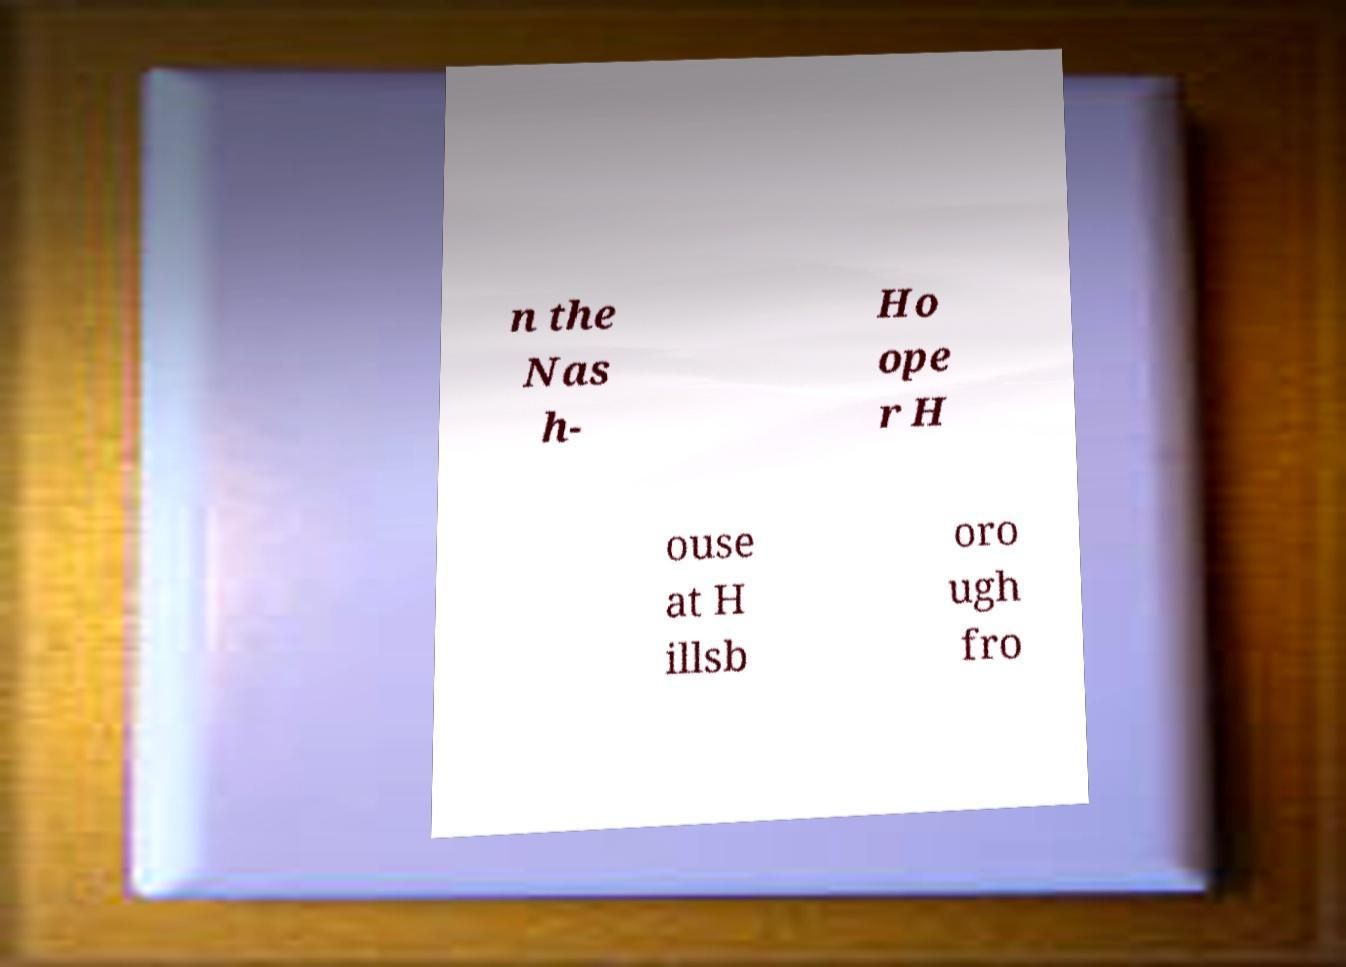Please identify and transcribe the text found in this image. n the Nas h- Ho ope r H ouse at H illsb oro ugh fro 